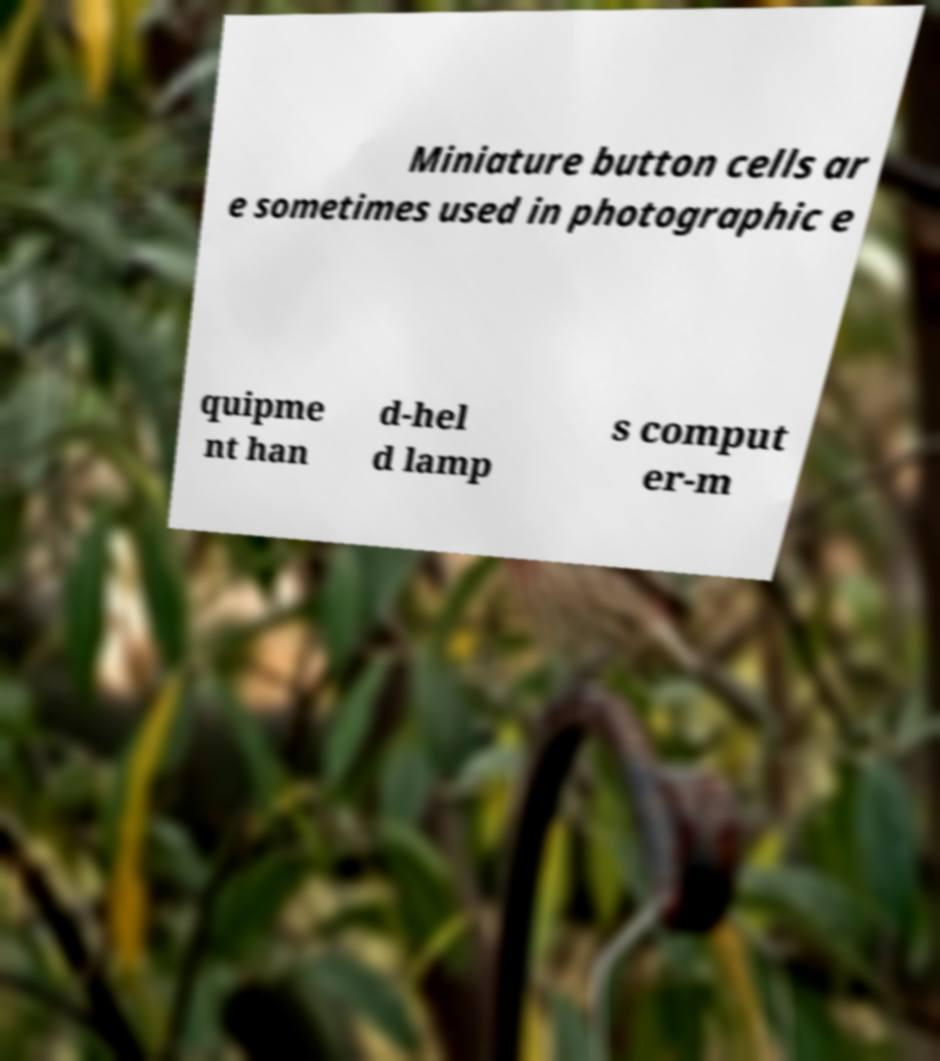Please read and relay the text visible in this image. What does it say? Miniature button cells ar e sometimes used in photographic e quipme nt han d-hel d lamp s comput er-m 